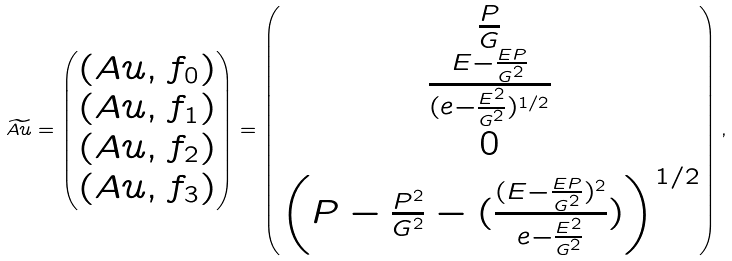<formula> <loc_0><loc_0><loc_500><loc_500>\widetilde { A u } = \begin{pmatrix} ( A u , f _ { 0 } ) \\ ( A u , f _ { 1 } ) \\ ( A u , f _ { 2 } ) \\ ( A u , f _ { 3 } ) \end{pmatrix} = \begin{pmatrix} \frac { P } { G } \\ \frac { E - \frac { E P } { G ^ { 2 } } } { ( e - \frac { E ^ { 2 } } { G ^ { 2 } } ) ^ { 1 / 2 } } \\ 0 \\ \left ( P - \frac { P ^ { 2 } } { G ^ { 2 } } - ( \frac { ( E - \frac { E P } { G ^ { 2 } } ) ^ { 2 } } { e - \frac { E ^ { 2 } } { G ^ { 2 } } } ) \right ) ^ { 1 / 2 } \end{pmatrix} ,</formula> 